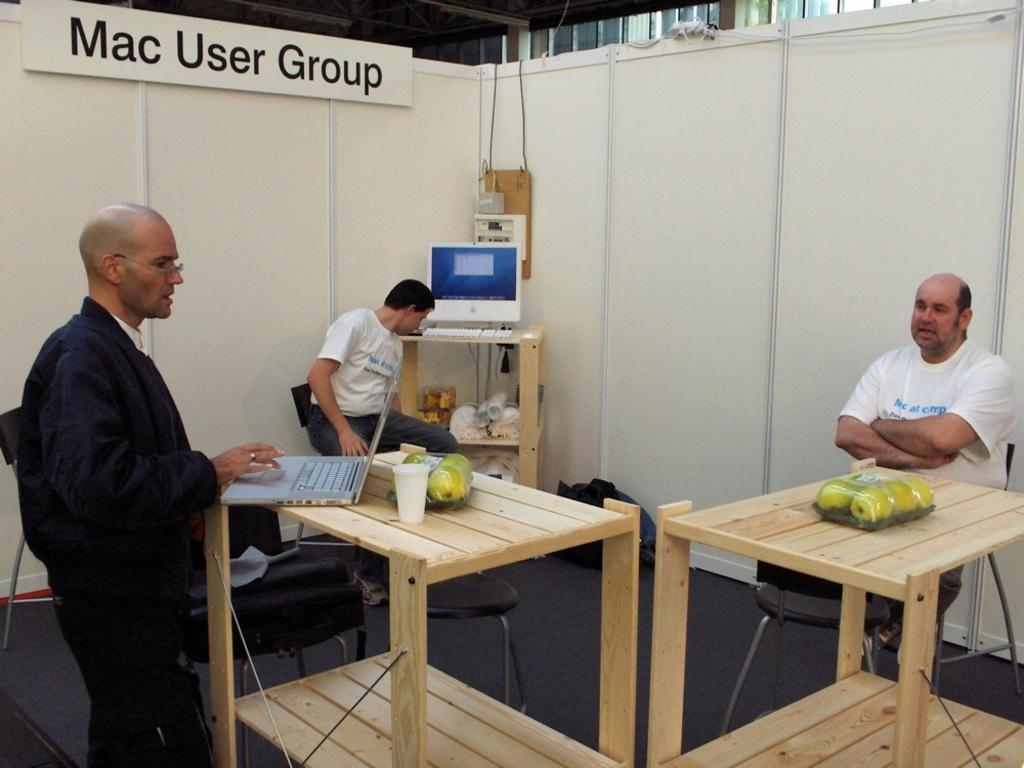Provide a one-sentence caption for the provided image. Three men in a large cubicle with a sign above them saying Mac User Group. 